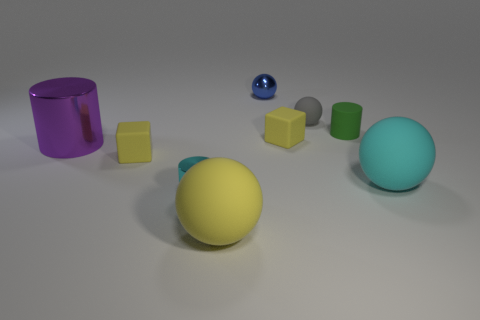There is a green rubber cylinder to the right of the tiny shiny object behind the big cylinder; what is its size?
Keep it short and to the point. Small. There is a blue sphere that is the same size as the gray rubber object; what material is it?
Your answer should be very brief. Metal. Are there any yellow spheres in front of the tiny gray thing?
Offer a terse response. Yes. Are there an equal number of small balls that are on the right side of the rubber cylinder and big cyan metal cylinders?
Offer a terse response. Yes. The gray object that is the same size as the green thing is what shape?
Provide a short and direct response. Sphere. What is the material of the tiny cyan thing?
Offer a very short reply. Metal. There is a object that is left of the tiny cyan object and in front of the purple object; what is its color?
Keep it short and to the point. Yellow. Is the number of small yellow rubber cubes on the right side of the cyan sphere the same as the number of tiny spheres in front of the large purple thing?
Your answer should be compact. Yes. There is another big object that is the same material as the blue thing; what color is it?
Offer a very short reply. Purple. Is the color of the tiny rubber ball the same as the small metal object in front of the small blue shiny ball?
Your response must be concise. No. 